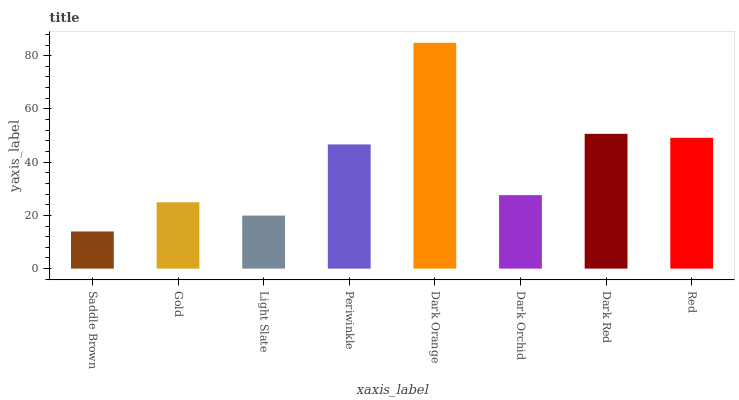Is Saddle Brown the minimum?
Answer yes or no. Yes. Is Dark Orange the maximum?
Answer yes or no. Yes. Is Gold the minimum?
Answer yes or no. No. Is Gold the maximum?
Answer yes or no. No. Is Gold greater than Saddle Brown?
Answer yes or no. Yes. Is Saddle Brown less than Gold?
Answer yes or no. Yes. Is Saddle Brown greater than Gold?
Answer yes or no. No. Is Gold less than Saddle Brown?
Answer yes or no. No. Is Periwinkle the high median?
Answer yes or no. Yes. Is Dark Orchid the low median?
Answer yes or no. Yes. Is Red the high median?
Answer yes or no. No. Is Gold the low median?
Answer yes or no. No. 